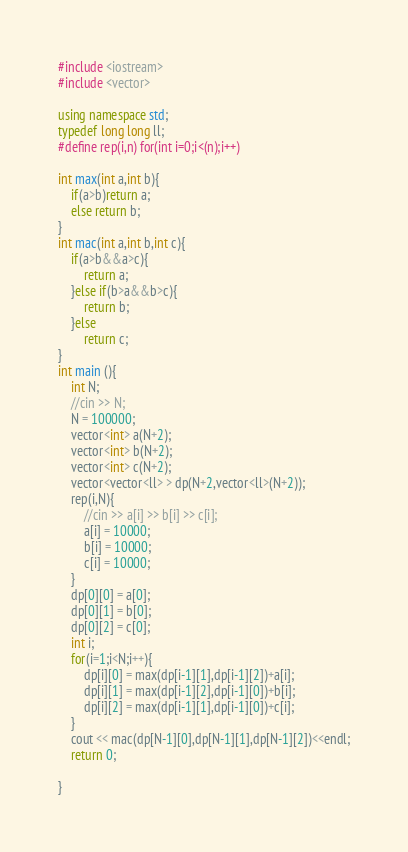<code> <loc_0><loc_0><loc_500><loc_500><_C++_>#include <iostream>
#include <vector>

using namespace std;
typedef long long ll;
#define rep(i,n) for(int i=0;i<(n);i++)

int max(int a,int b){
    if(a>b)return a;
    else return b;
}
int mac(int a,int b,int c){
    if(a>b&&a>c){
        return a;
    }else if(b>a&&b>c){
        return b;
    }else 
        return c;
}
int main (){
    int N;
    //cin >> N;
    N = 100000;
    vector<int> a(N+2);
    vector<int> b(N+2);
    vector<int> c(N+2);
    vector<vector<ll> > dp(N+2,vector<ll>(N+2));
    rep(i,N){
        //cin >> a[i] >> b[i] >> c[i];
        a[i] = 10000;
        b[i] = 10000;
        c[i] = 10000;
    }
    dp[0][0] = a[0];
    dp[0][1] = b[0];
    dp[0][2] = c[0];
    int i;
    for(i=1;i<N;i++){
        dp[i][0] = max(dp[i-1][1],dp[i-1][2])+a[i];
        dp[i][1] = max(dp[i-1][2],dp[i-1][0])+b[i];
        dp[i][2] = max(dp[i-1][1],dp[i-1][0])+c[i];
    }
    cout << mac(dp[N-1][0],dp[N-1][1],dp[N-1][2])<<endl;
    return 0;

}</code> 